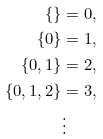Convert formula to latex. <formula><loc_0><loc_0><loc_500><loc_500>\{ \} & = 0 , \\ \{ 0 \} & = 1 , \\ \{ 0 , 1 \} & = 2 , \\ \{ 0 , 1 , 2 \} & = 3 , \\ & \vdots</formula> 